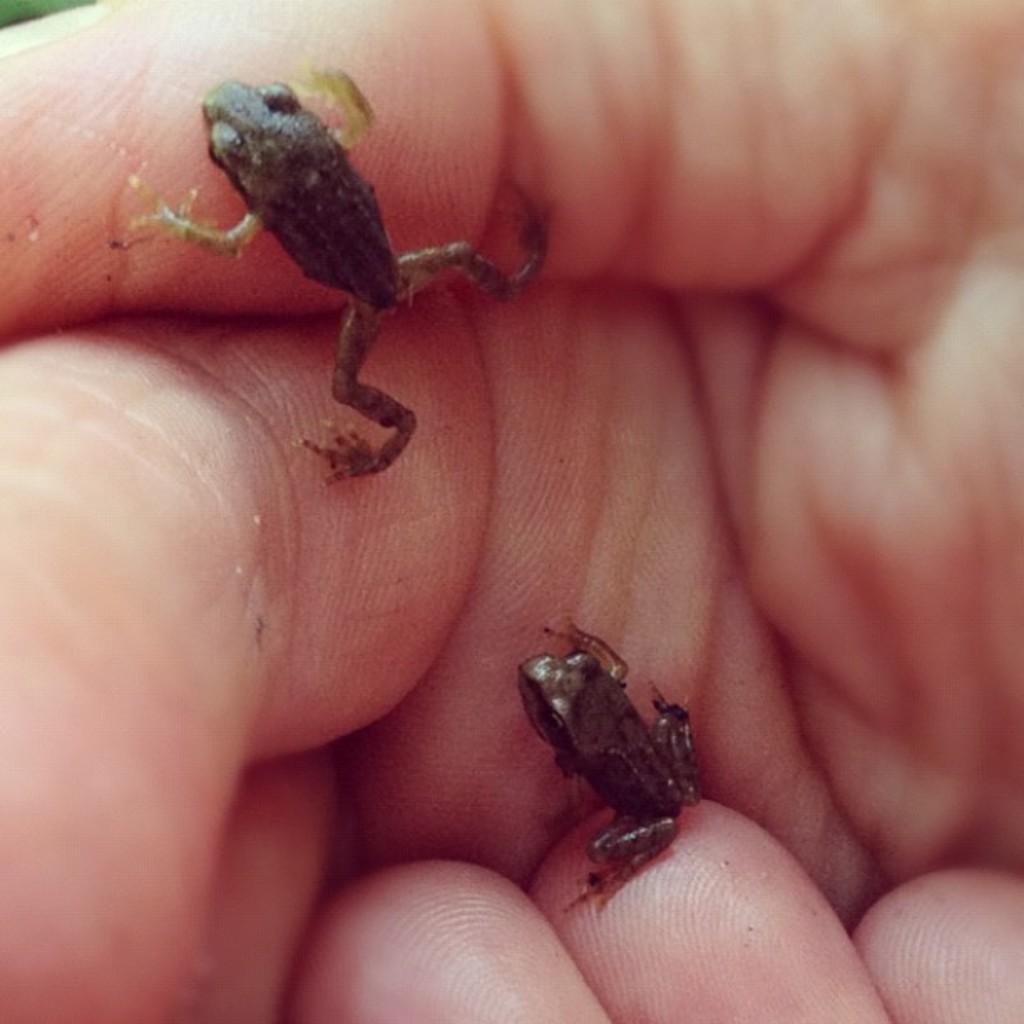How would you summarize this image in a sentence or two? In this image, there are two frogs on a hand of a person. At the bottom of this image, there is another hand. 